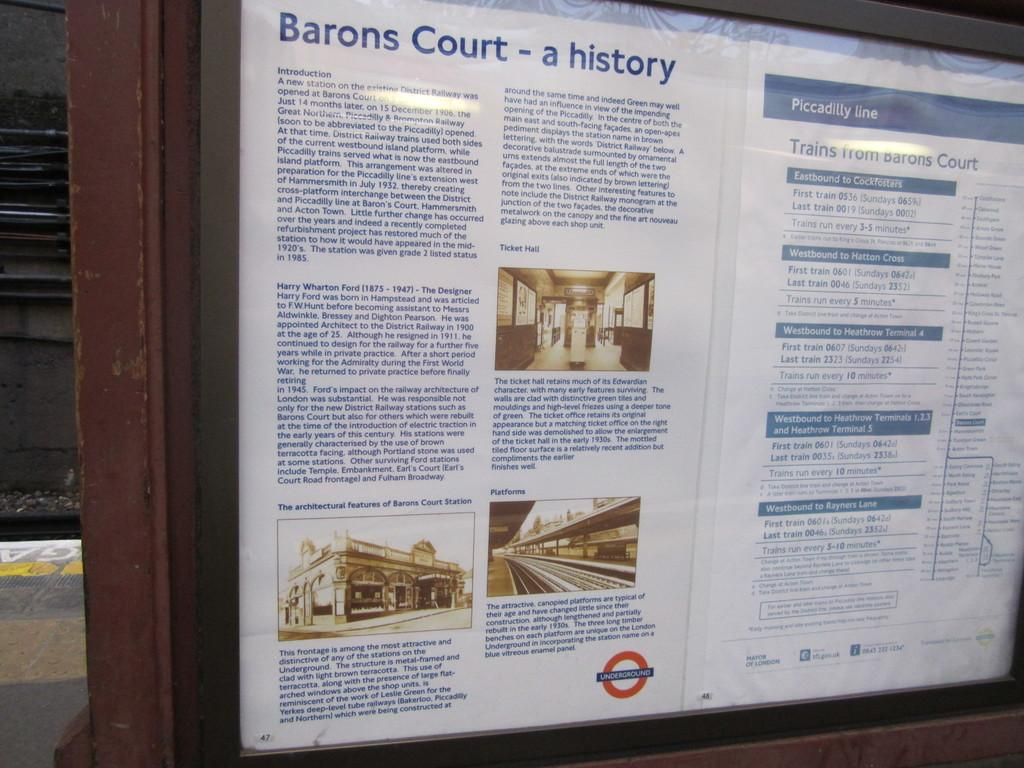<image>
Create a compact narrative representing the image presented. An outdoor informational sign details the history of Barons Court. 